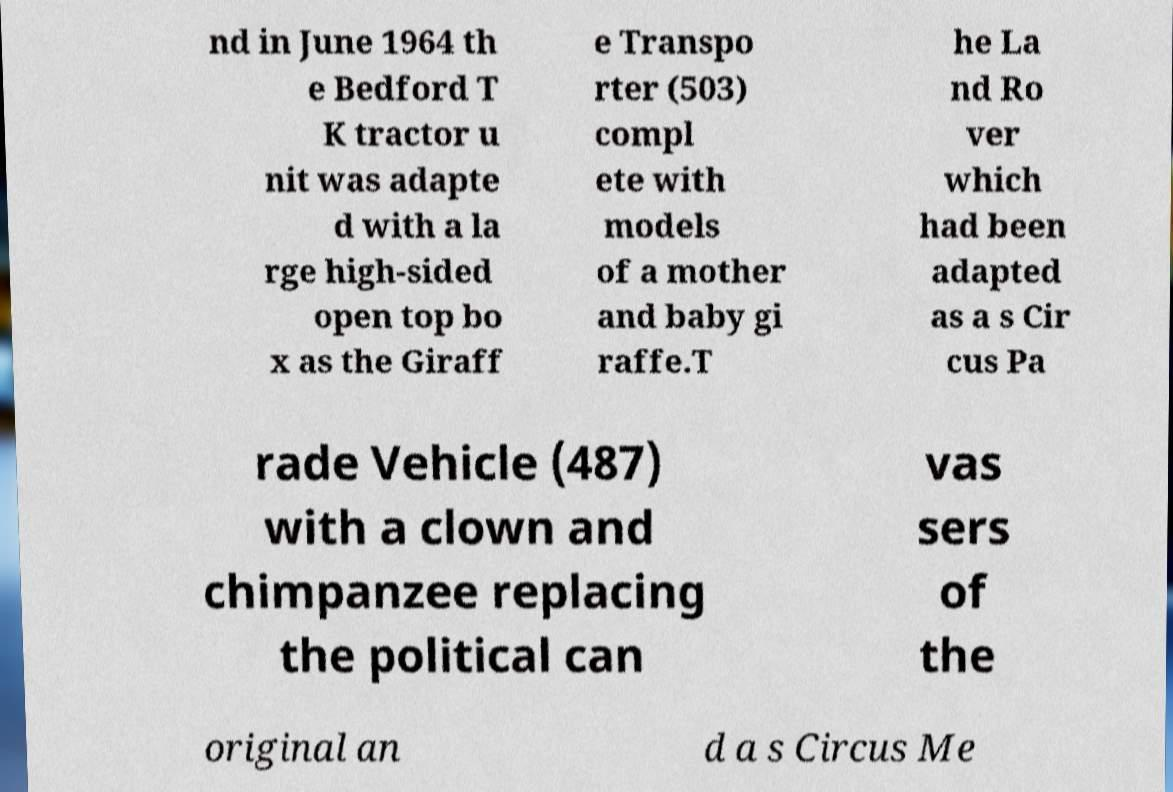Could you assist in decoding the text presented in this image and type it out clearly? nd in June 1964 th e Bedford T K tractor u nit was adapte d with a la rge high-sided open top bo x as the Giraff e Transpo rter (503) compl ete with models of a mother and baby gi raffe.T he La nd Ro ver which had been adapted as a s Cir cus Pa rade Vehicle (487) with a clown and chimpanzee replacing the political can vas sers of the original an d a s Circus Me 